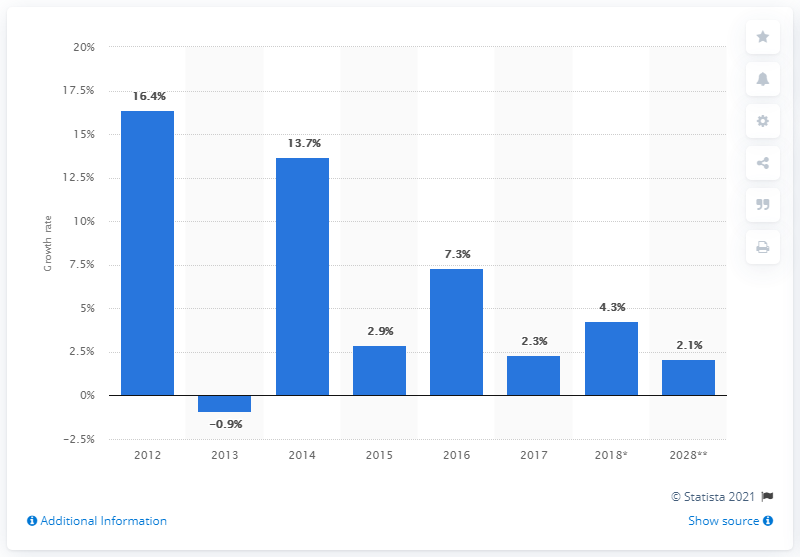What could have caused the spike in growth rate between 2012 and 2014? Growth rates can be influenced by various factors such as economic policies, market demand, investments, and global economic conditions. The spike you’re referring to between 2012 and 2014 could be the result of positive market trends or impactful fiscal policies that stimulated growth during that period. Further analysis of historical economic events or policies could shed more light on the specific causes. 